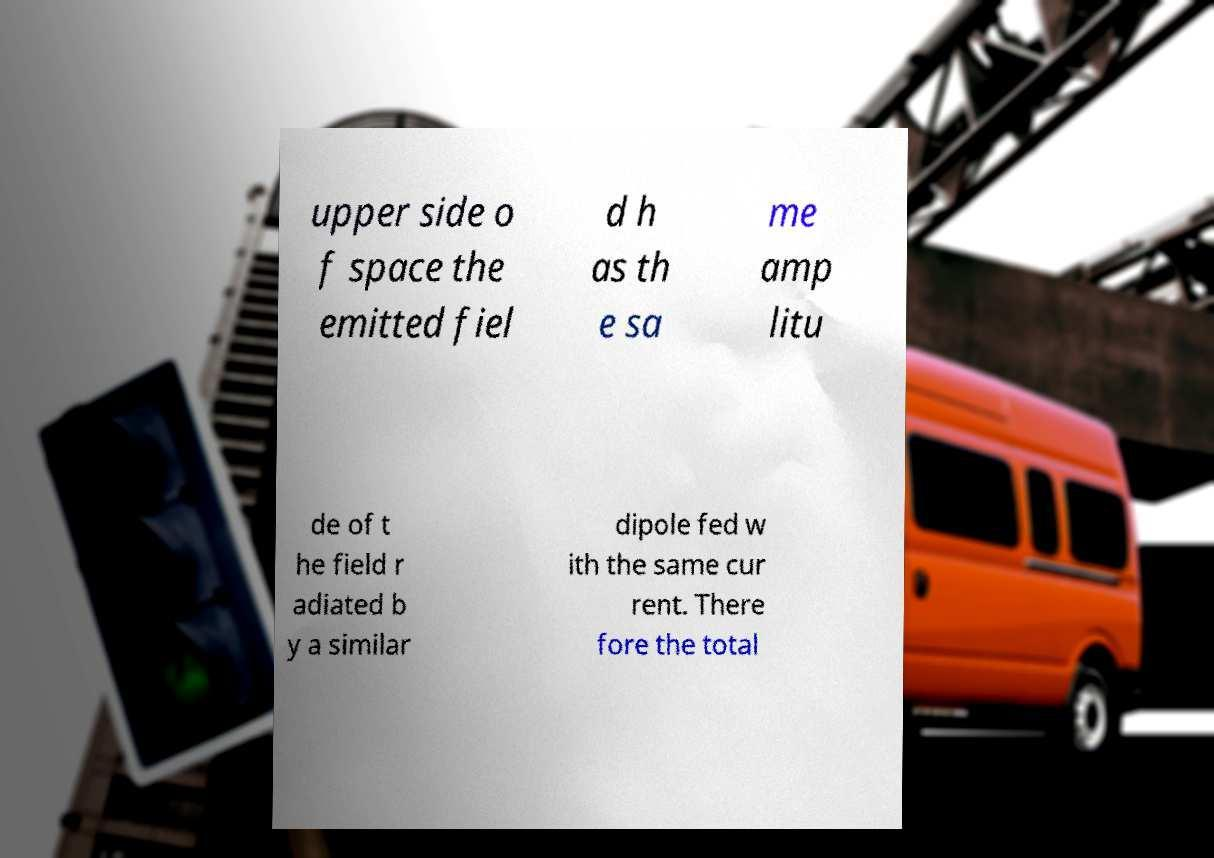Could you assist in decoding the text presented in this image and type it out clearly? upper side o f space the emitted fiel d h as th e sa me amp litu de of t he field r adiated b y a similar dipole fed w ith the same cur rent. There fore the total 